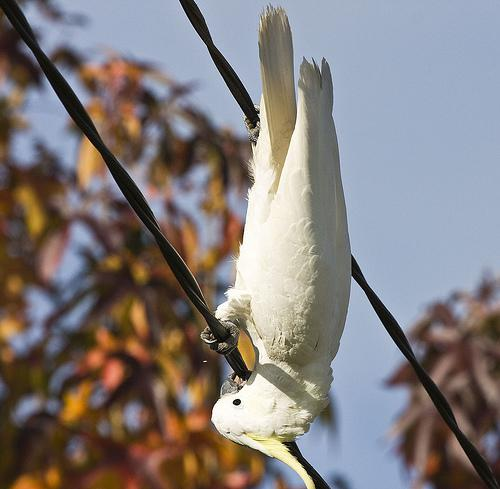Question: who is in the pic?
Choices:
A. A dog.
B. A bird.
C. A snail.
D. A slug.
Answer with the letter. Answer: B Question: what is the color of the bird?
Choices:
A. Cream colored.
B. Alabaster.
C. Ivory.
D. White.
Answer with the letter. Answer: D Question: when was the pic taken?
Choices:
A. After sunrise.
B. During the day.
C. Before sunset.
D. In the morning.
Answer with the letter. Answer: B 